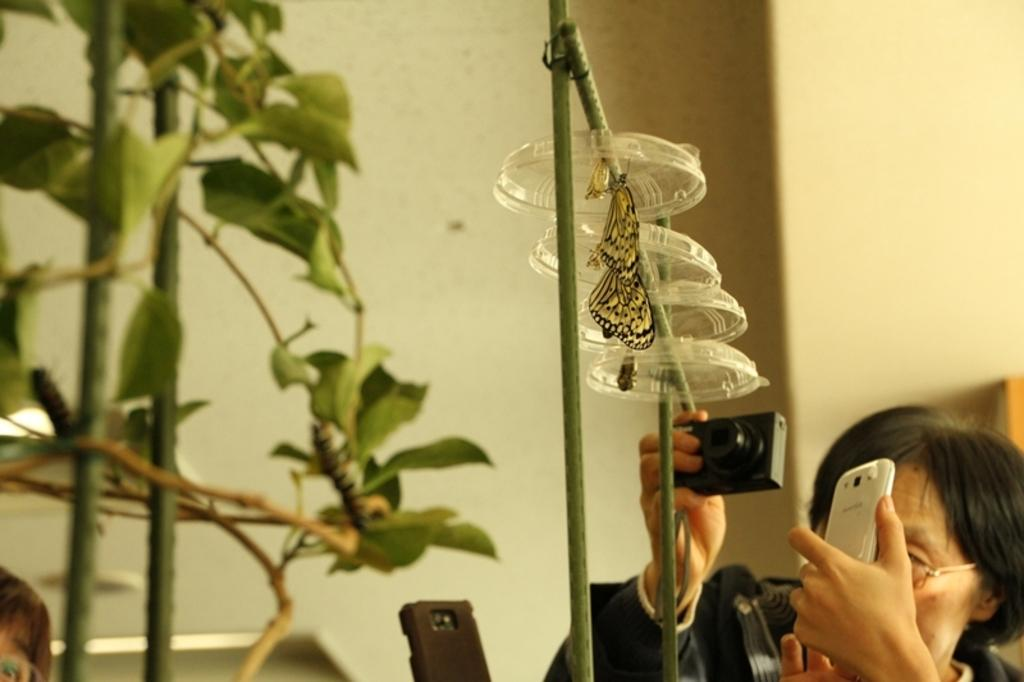Who is the main subject in the image? There is a woman in the image. What is the woman doing in the image? The woman is taking pictures. What can be seen in the image besides the woman? There are butterflies in the image, and they are on caps hanged to a stick. What is located on the left side of the image? There is a plant on the left side of the image. What is visible in the background of the image? There is a wall in the background of the image. What type of weather can be seen in the image? There is no information about the weather in the image. Can you tell me how many clams are present in the image? There are no clams present in the image. 